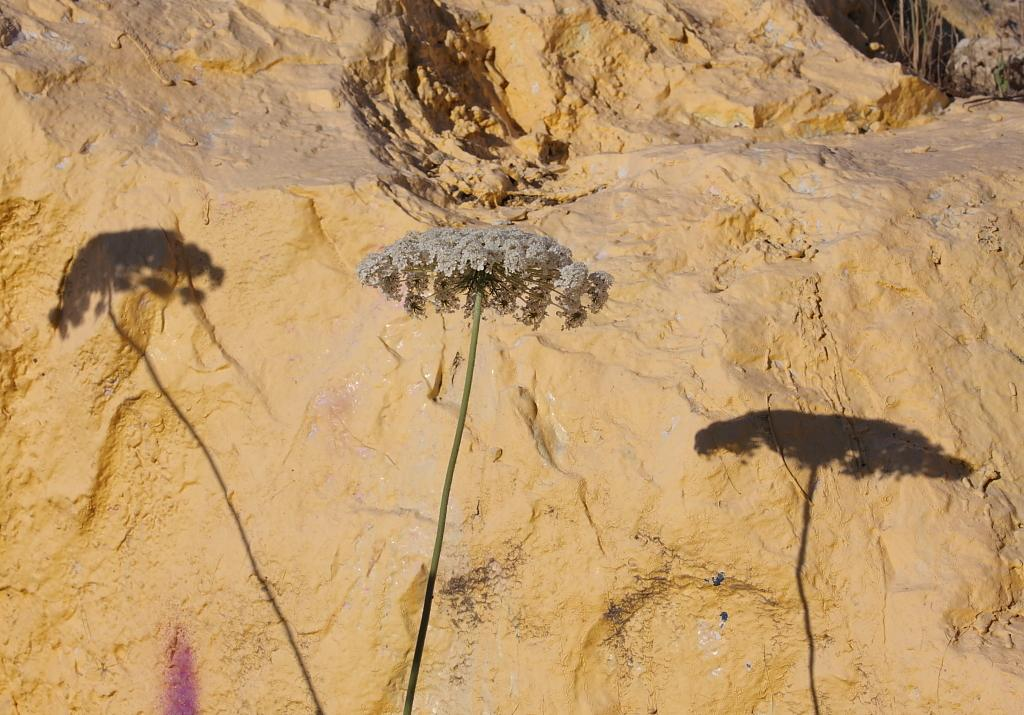What is the main subject of the image? There is a flower in the image. Can you describe the color of the flower? The flower is white. What can be seen in the background of the image? There is a rock in the background of the image. What is the color of the rock? The rock is cream-colored. What type of toothpaste is being used to decorate the flower in the image? There is no toothpaste present in the image, and the flower is not being decorated. 